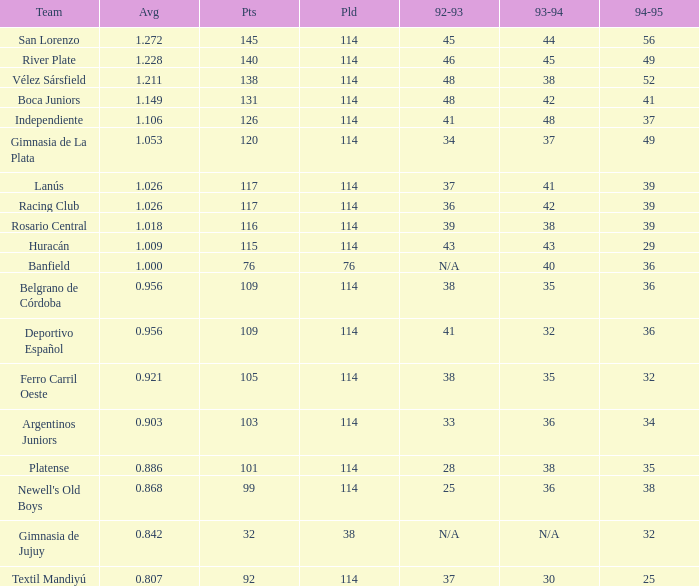Name the team for 1993-94 for 32 Deportivo Español. Could you parse the entire table? {'header': ['Team', 'Avg', 'Pts', 'Pld', '92-93', '93-94', '94-95'], 'rows': [['San Lorenzo', '1.272', '145', '114', '45', '44', '56'], ['River Plate', '1.228', '140', '114', '46', '45', '49'], ['Vélez Sársfield', '1.211', '138', '114', '48', '38', '52'], ['Boca Juniors', '1.149', '131', '114', '48', '42', '41'], ['Independiente', '1.106', '126', '114', '41', '48', '37'], ['Gimnasia de La Plata', '1.053', '120', '114', '34', '37', '49'], ['Lanús', '1.026', '117', '114', '37', '41', '39'], ['Racing Club', '1.026', '117', '114', '36', '42', '39'], ['Rosario Central', '1.018', '116', '114', '39', '38', '39'], ['Huracán', '1.009', '115', '114', '43', '43', '29'], ['Banfield', '1.000', '76', '76', 'N/A', '40', '36'], ['Belgrano de Córdoba', '0.956', '109', '114', '38', '35', '36'], ['Deportivo Español', '0.956', '109', '114', '41', '32', '36'], ['Ferro Carril Oeste', '0.921', '105', '114', '38', '35', '32'], ['Argentinos Juniors', '0.903', '103', '114', '33', '36', '34'], ['Platense', '0.886', '101', '114', '28', '38', '35'], ["Newell's Old Boys", '0.868', '99', '114', '25', '36', '38'], ['Gimnasia de Jujuy', '0.842', '32', '38', 'N/A', 'N/A', '32'], ['Textil Mandiyú', '0.807', '92', '114', '37', '30', '25']]} 